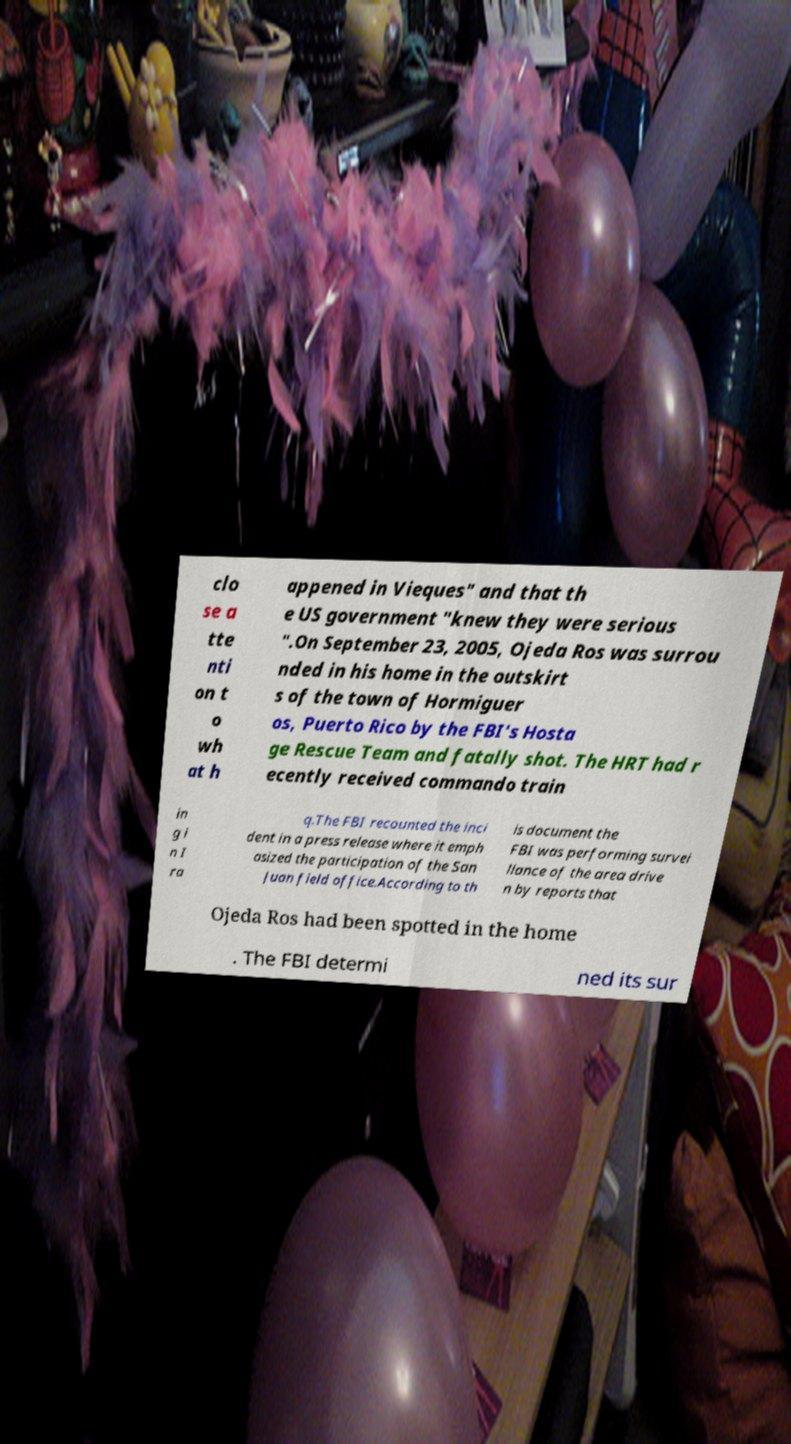What messages or text are displayed in this image? I need them in a readable, typed format. clo se a tte nti on t o wh at h appened in Vieques" and that th e US government "knew they were serious ".On September 23, 2005, Ojeda Ros was surrou nded in his home in the outskirt s of the town of Hormiguer os, Puerto Rico by the FBI's Hosta ge Rescue Team and fatally shot. The HRT had r ecently received commando train in g i n I ra q.The FBI recounted the inci dent in a press release where it emph asized the participation of the San Juan field office.According to th is document the FBI was performing survei llance of the area drive n by reports that Ojeda Ros had been spotted in the home . The FBI determi ned its sur 